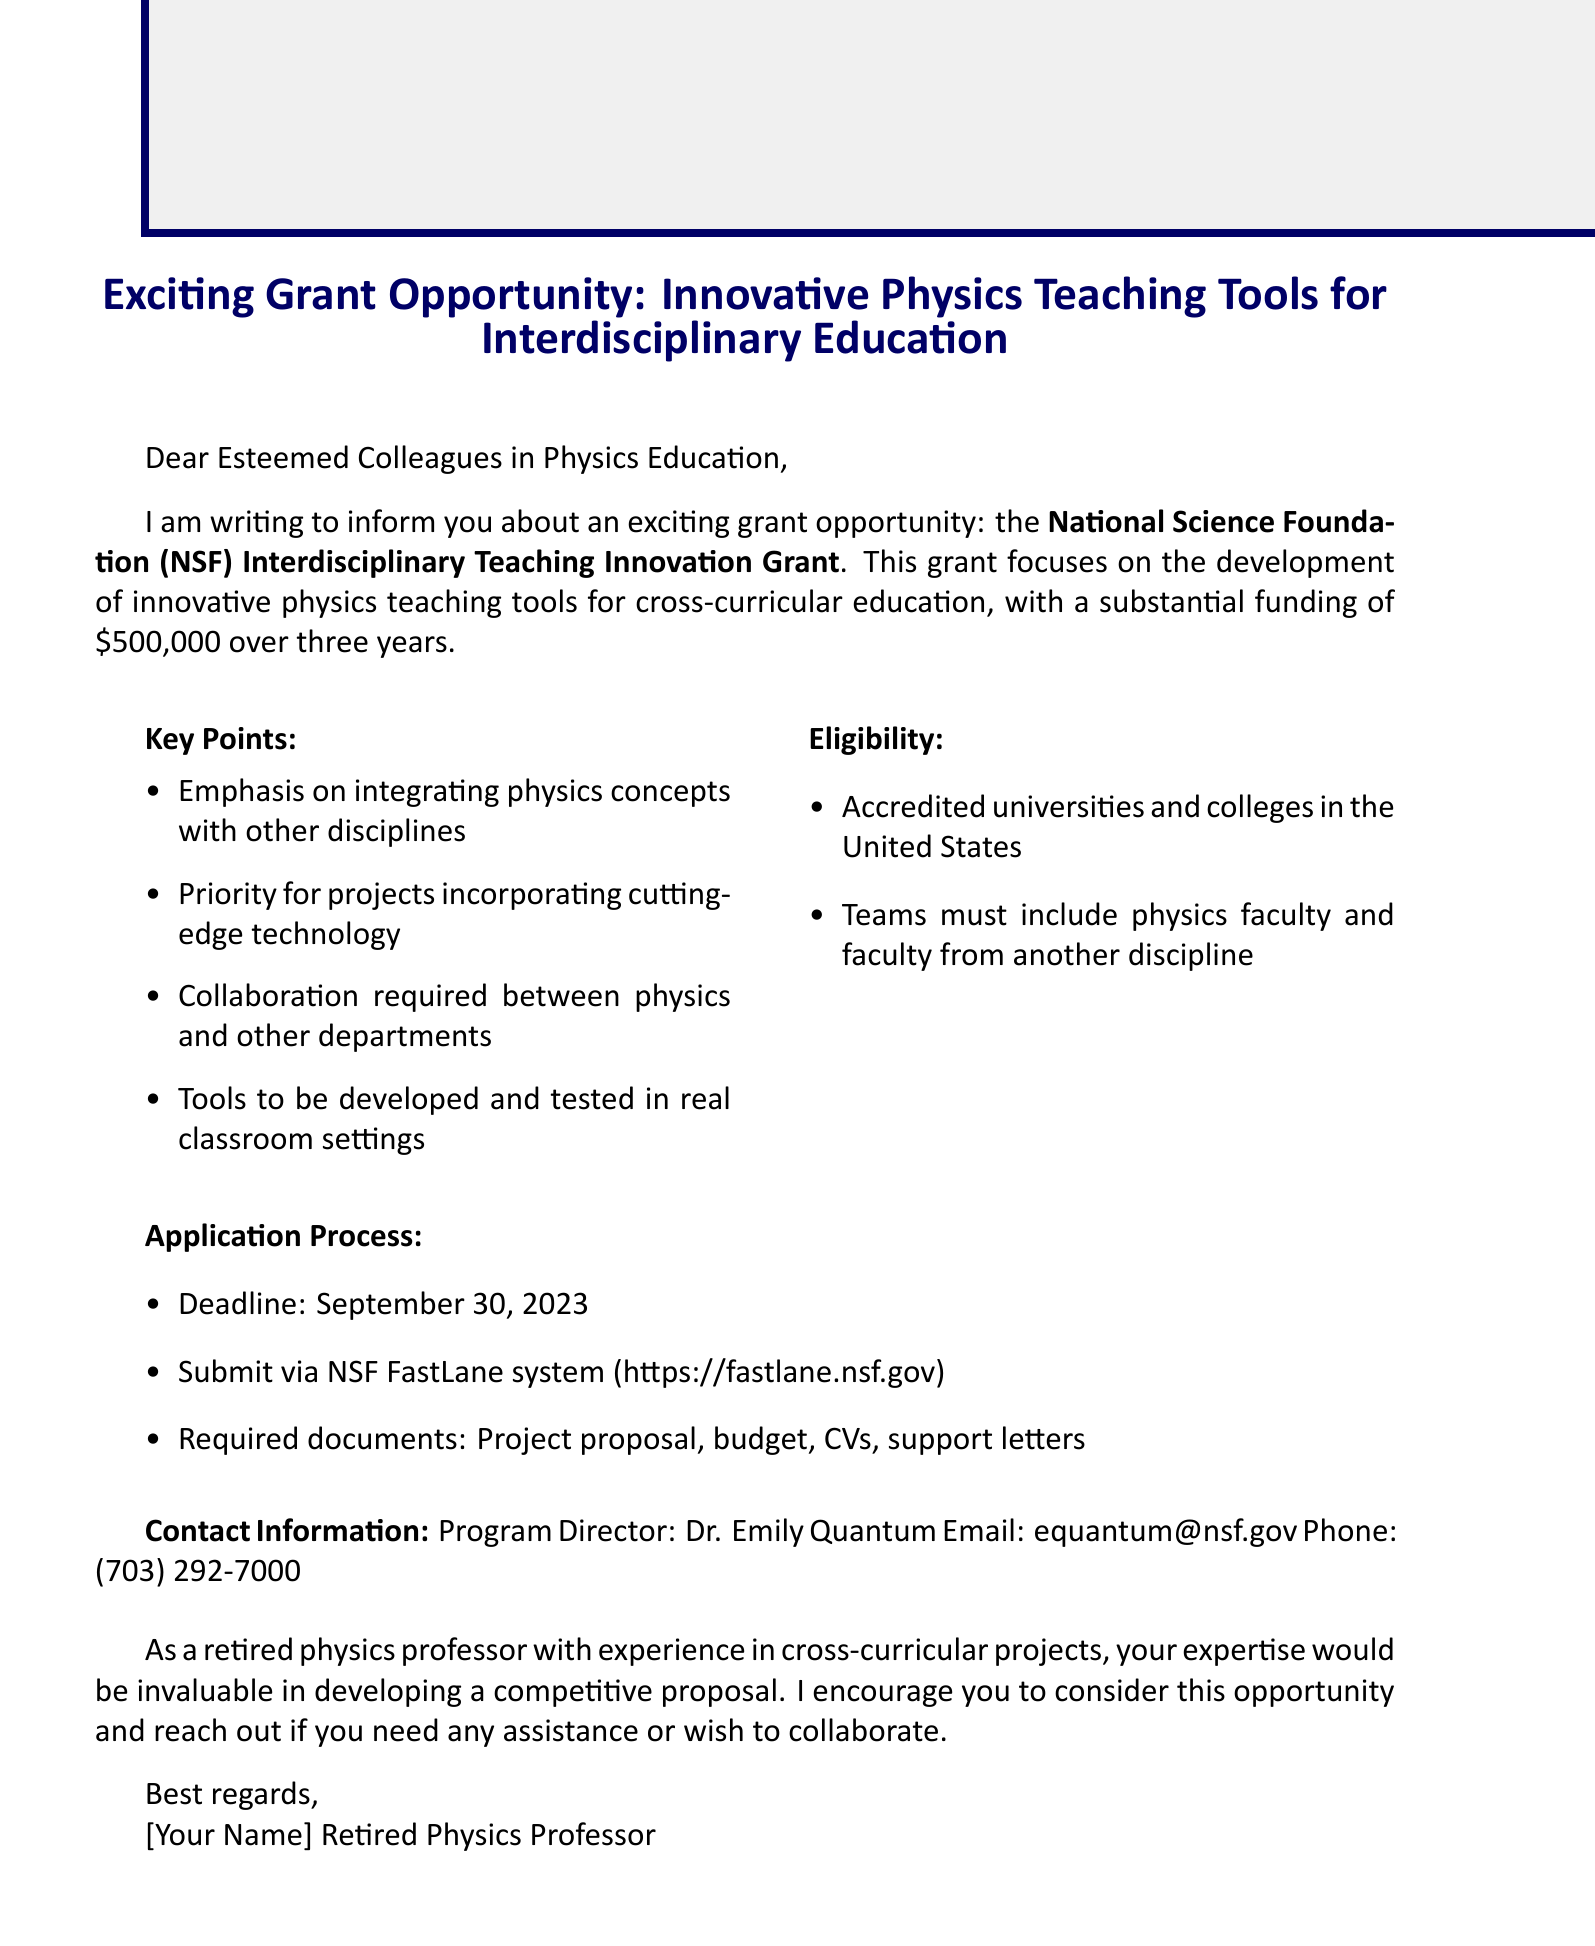What is the grant name? The grant name is stated clearly in the introduction section of the document as the National Science Foundation (NSF) Interdisciplinary Teaching Innovation Grant.
Answer: National Science Foundation (NSF) Interdisciplinary Teaching Innovation Grant What is the total grant amount? The total grant amount is specified in the introduction section as $500,000 over three years.
Answer: $500,000 over three years What is the submission deadline? The submission deadline for the grant application is provided in the application process section as September 30, 2023.
Answer: September 30, 2023 Who is the program director? The program director’s name is mentioned in the contact information section as Dr. Emily Quantum.
Answer: Dr. Emily Quantum What types of technology should projects incorporate? The key points section highlights the priority for projects that incorporate cutting-edge technologies like virtual reality or artificial intelligence.
Answer: virtual reality or artificial intelligence How many faculty members are required from different disciplines? The eligibility section states that teams must include at least one physics faculty member and one faculty member from another discipline.
Answer: one What is required for collaboration? Collaboration is mandated between physics departments and at least one other academic department according to the key points section.
Answer: at least one other academic department What is the required maximum length for the project proposal? The maximum length for the project proposal is mentioned in the application process section as 15 pages.
Answer: 15 pages Which system should submissions be made through? The application process specifies that submissions should be made via the NSF FastLane system.
Answer: NSF FastLane system 